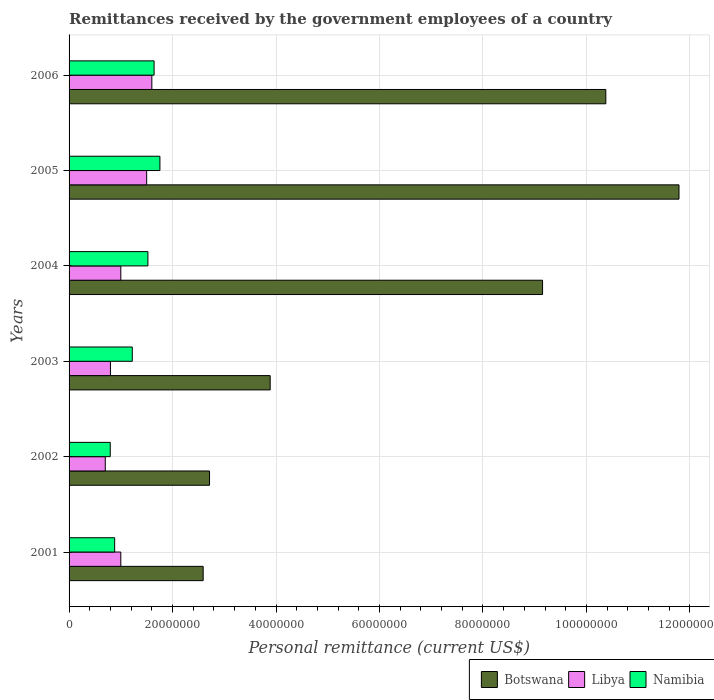How many different coloured bars are there?
Your answer should be compact. 3. How many groups of bars are there?
Your answer should be compact. 6. Are the number of bars on each tick of the Y-axis equal?
Offer a very short reply. Yes. How many bars are there on the 4th tick from the bottom?
Offer a very short reply. 3. What is the label of the 6th group of bars from the top?
Offer a very short reply. 2001. What is the remittances received by the government employees in Botswana in 2002?
Your response must be concise. 2.72e+07. Across all years, what is the maximum remittances received by the government employees in Libya?
Your answer should be very brief. 1.60e+07. Across all years, what is the minimum remittances received by the government employees in Botswana?
Provide a short and direct response. 2.59e+07. In which year was the remittances received by the government employees in Libya maximum?
Ensure brevity in your answer.  2006. What is the total remittances received by the government employees in Libya in the graph?
Your answer should be very brief. 6.60e+07. What is the difference between the remittances received by the government employees in Botswana in 2001 and that in 2005?
Provide a succinct answer. -9.20e+07. What is the difference between the remittances received by the government employees in Namibia in 2005 and the remittances received by the government employees in Botswana in 2003?
Your response must be concise. -2.13e+07. What is the average remittances received by the government employees in Botswana per year?
Provide a succinct answer. 6.75e+07. In the year 2006, what is the difference between the remittances received by the government employees in Libya and remittances received by the government employees in Namibia?
Keep it short and to the point. -4.33e+05. Is the remittances received by the government employees in Libya in 2003 less than that in 2004?
Provide a succinct answer. Yes. What is the difference between the highest and the second highest remittances received by the government employees in Namibia?
Offer a very short reply. 1.13e+06. What is the difference between the highest and the lowest remittances received by the government employees in Botswana?
Your response must be concise. 9.20e+07. In how many years, is the remittances received by the government employees in Namibia greater than the average remittances received by the government employees in Namibia taken over all years?
Make the answer very short. 3. What does the 1st bar from the top in 2003 represents?
Provide a succinct answer. Namibia. What does the 3rd bar from the bottom in 2001 represents?
Provide a succinct answer. Namibia. How many bars are there?
Keep it short and to the point. 18. Are all the bars in the graph horizontal?
Give a very brief answer. Yes. Are the values on the major ticks of X-axis written in scientific E-notation?
Ensure brevity in your answer.  No. Does the graph contain any zero values?
Provide a succinct answer. No. Where does the legend appear in the graph?
Offer a terse response. Bottom right. How many legend labels are there?
Your answer should be compact. 3. How are the legend labels stacked?
Give a very brief answer. Horizontal. What is the title of the graph?
Give a very brief answer. Remittances received by the government employees of a country. Does "Italy" appear as one of the legend labels in the graph?
Make the answer very short. No. What is the label or title of the X-axis?
Provide a short and direct response. Personal remittance (current US$). What is the Personal remittance (current US$) of Botswana in 2001?
Give a very brief answer. 2.59e+07. What is the Personal remittance (current US$) in Namibia in 2001?
Your answer should be very brief. 8.82e+06. What is the Personal remittance (current US$) of Botswana in 2002?
Make the answer very short. 2.72e+07. What is the Personal remittance (current US$) in Namibia in 2002?
Your response must be concise. 7.96e+06. What is the Personal remittance (current US$) of Botswana in 2003?
Ensure brevity in your answer.  3.89e+07. What is the Personal remittance (current US$) in Libya in 2003?
Your answer should be very brief. 8.00e+06. What is the Personal remittance (current US$) of Namibia in 2003?
Keep it short and to the point. 1.22e+07. What is the Personal remittance (current US$) in Botswana in 2004?
Keep it short and to the point. 9.15e+07. What is the Personal remittance (current US$) in Namibia in 2004?
Offer a terse response. 1.52e+07. What is the Personal remittance (current US$) of Botswana in 2005?
Give a very brief answer. 1.18e+08. What is the Personal remittance (current US$) in Libya in 2005?
Provide a succinct answer. 1.50e+07. What is the Personal remittance (current US$) of Namibia in 2005?
Offer a very short reply. 1.76e+07. What is the Personal remittance (current US$) of Botswana in 2006?
Your answer should be very brief. 1.04e+08. What is the Personal remittance (current US$) in Libya in 2006?
Your response must be concise. 1.60e+07. What is the Personal remittance (current US$) in Namibia in 2006?
Your answer should be very brief. 1.64e+07. Across all years, what is the maximum Personal remittance (current US$) in Botswana?
Your answer should be compact. 1.18e+08. Across all years, what is the maximum Personal remittance (current US$) in Libya?
Provide a succinct answer. 1.60e+07. Across all years, what is the maximum Personal remittance (current US$) in Namibia?
Provide a short and direct response. 1.76e+07. Across all years, what is the minimum Personal remittance (current US$) in Botswana?
Offer a very short reply. 2.59e+07. Across all years, what is the minimum Personal remittance (current US$) of Namibia?
Your response must be concise. 7.96e+06. What is the total Personal remittance (current US$) in Botswana in the graph?
Provide a short and direct response. 4.05e+08. What is the total Personal remittance (current US$) in Libya in the graph?
Offer a very short reply. 6.60e+07. What is the total Personal remittance (current US$) in Namibia in the graph?
Offer a very short reply. 7.82e+07. What is the difference between the Personal remittance (current US$) in Botswana in 2001 and that in 2002?
Ensure brevity in your answer.  -1.23e+06. What is the difference between the Personal remittance (current US$) of Libya in 2001 and that in 2002?
Make the answer very short. 3.00e+06. What is the difference between the Personal remittance (current US$) of Namibia in 2001 and that in 2002?
Keep it short and to the point. 8.56e+05. What is the difference between the Personal remittance (current US$) in Botswana in 2001 and that in 2003?
Provide a succinct answer. -1.30e+07. What is the difference between the Personal remittance (current US$) of Namibia in 2001 and that in 2003?
Provide a succinct answer. -3.40e+06. What is the difference between the Personal remittance (current US$) in Botswana in 2001 and that in 2004?
Make the answer very short. -6.56e+07. What is the difference between the Personal remittance (current US$) in Namibia in 2001 and that in 2004?
Offer a terse response. -6.42e+06. What is the difference between the Personal remittance (current US$) of Botswana in 2001 and that in 2005?
Provide a succinct answer. -9.20e+07. What is the difference between the Personal remittance (current US$) of Libya in 2001 and that in 2005?
Keep it short and to the point. -5.00e+06. What is the difference between the Personal remittance (current US$) in Namibia in 2001 and that in 2005?
Your response must be concise. -8.75e+06. What is the difference between the Personal remittance (current US$) in Botswana in 2001 and that in 2006?
Make the answer very short. -7.78e+07. What is the difference between the Personal remittance (current US$) in Libya in 2001 and that in 2006?
Your answer should be very brief. -6.00e+06. What is the difference between the Personal remittance (current US$) in Namibia in 2001 and that in 2006?
Provide a succinct answer. -7.62e+06. What is the difference between the Personal remittance (current US$) of Botswana in 2002 and that in 2003?
Your answer should be very brief. -1.17e+07. What is the difference between the Personal remittance (current US$) of Namibia in 2002 and that in 2003?
Offer a terse response. -4.26e+06. What is the difference between the Personal remittance (current US$) in Botswana in 2002 and that in 2004?
Your answer should be compact. -6.44e+07. What is the difference between the Personal remittance (current US$) in Libya in 2002 and that in 2004?
Give a very brief answer. -3.00e+06. What is the difference between the Personal remittance (current US$) of Namibia in 2002 and that in 2004?
Your response must be concise. -7.28e+06. What is the difference between the Personal remittance (current US$) in Botswana in 2002 and that in 2005?
Your answer should be compact. -9.07e+07. What is the difference between the Personal remittance (current US$) in Libya in 2002 and that in 2005?
Ensure brevity in your answer.  -8.00e+06. What is the difference between the Personal remittance (current US$) in Namibia in 2002 and that in 2005?
Your answer should be compact. -9.60e+06. What is the difference between the Personal remittance (current US$) of Botswana in 2002 and that in 2006?
Keep it short and to the point. -7.66e+07. What is the difference between the Personal remittance (current US$) in Libya in 2002 and that in 2006?
Your response must be concise. -9.00e+06. What is the difference between the Personal remittance (current US$) of Namibia in 2002 and that in 2006?
Your answer should be very brief. -8.47e+06. What is the difference between the Personal remittance (current US$) of Botswana in 2003 and that in 2004?
Your response must be concise. -5.26e+07. What is the difference between the Personal remittance (current US$) of Namibia in 2003 and that in 2004?
Your answer should be compact. -3.02e+06. What is the difference between the Personal remittance (current US$) of Botswana in 2003 and that in 2005?
Keep it short and to the point. -7.90e+07. What is the difference between the Personal remittance (current US$) in Libya in 2003 and that in 2005?
Offer a terse response. -7.00e+06. What is the difference between the Personal remittance (current US$) in Namibia in 2003 and that in 2005?
Offer a very short reply. -5.34e+06. What is the difference between the Personal remittance (current US$) in Botswana in 2003 and that in 2006?
Ensure brevity in your answer.  -6.49e+07. What is the difference between the Personal remittance (current US$) of Libya in 2003 and that in 2006?
Give a very brief answer. -8.00e+06. What is the difference between the Personal remittance (current US$) in Namibia in 2003 and that in 2006?
Provide a succinct answer. -4.22e+06. What is the difference between the Personal remittance (current US$) of Botswana in 2004 and that in 2005?
Give a very brief answer. -2.64e+07. What is the difference between the Personal remittance (current US$) of Libya in 2004 and that in 2005?
Your response must be concise. -5.00e+06. What is the difference between the Personal remittance (current US$) in Namibia in 2004 and that in 2005?
Offer a terse response. -2.32e+06. What is the difference between the Personal remittance (current US$) in Botswana in 2004 and that in 2006?
Provide a succinct answer. -1.22e+07. What is the difference between the Personal remittance (current US$) in Libya in 2004 and that in 2006?
Give a very brief answer. -6.00e+06. What is the difference between the Personal remittance (current US$) in Namibia in 2004 and that in 2006?
Your answer should be very brief. -1.20e+06. What is the difference between the Personal remittance (current US$) of Botswana in 2005 and that in 2006?
Offer a very short reply. 1.41e+07. What is the difference between the Personal remittance (current US$) of Namibia in 2005 and that in 2006?
Your answer should be very brief. 1.13e+06. What is the difference between the Personal remittance (current US$) in Botswana in 2001 and the Personal remittance (current US$) in Libya in 2002?
Offer a terse response. 1.89e+07. What is the difference between the Personal remittance (current US$) of Botswana in 2001 and the Personal remittance (current US$) of Namibia in 2002?
Offer a very short reply. 1.80e+07. What is the difference between the Personal remittance (current US$) in Libya in 2001 and the Personal remittance (current US$) in Namibia in 2002?
Offer a terse response. 2.04e+06. What is the difference between the Personal remittance (current US$) of Botswana in 2001 and the Personal remittance (current US$) of Libya in 2003?
Provide a short and direct response. 1.79e+07. What is the difference between the Personal remittance (current US$) in Botswana in 2001 and the Personal remittance (current US$) in Namibia in 2003?
Offer a terse response. 1.37e+07. What is the difference between the Personal remittance (current US$) in Libya in 2001 and the Personal remittance (current US$) in Namibia in 2003?
Ensure brevity in your answer.  -2.22e+06. What is the difference between the Personal remittance (current US$) of Botswana in 2001 and the Personal remittance (current US$) of Libya in 2004?
Keep it short and to the point. 1.59e+07. What is the difference between the Personal remittance (current US$) of Botswana in 2001 and the Personal remittance (current US$) of Namibia in 2004?
Give a very brief answer. 1.07e+07. What is the difference between the Personal remittance (current US$) of Libya in 2001 and the Personal remittance (current US$) of Namibia in 2004?
Offer a terse response. -5.24e+06. What is the difference between the Personal remittance (current US$) of Botswana in 2001 and the Personal remittance (current US$) of Libya in 2005?
Provide a succinct answer. 1.09e+07. What is the difference between the Personal remittance (current US$) in Botswana in 2001 and the Personal remittance (current US$) in Namibia in 2005?
Your answer should be compact. 8.36e+06. What is the difference between the Personal remittance (current US$) of Libya in 2001 and the Personal remittance (current US$) of Namibia in 2005?
Make the answer very short. -7.56e+06. What is the difference between the Personal remittance (current US$) of Botswana in 2001 and the Personal remittance (current US$) of Libya in 2006?
Your answer should be very brief. 9.92e+06. What is the difference between the Personal remittance (current US$) of Botswana in 2001 and the Personal remittance (current US$) of Namibia in 2006?
Your answer should be very brief. 9.49e+06. What is the difference between the Personal remittance (current US$) in Libya in 2001 and the Personal remittance (current US$) in Namibia in 2006?
Your answer should be compact. -6.43e+06. What is the difference between the Personal remittance (current US$) in Botswana in 2002 and the Personal remittance (current US$) in Libya in 2003?
Provide a succinct answer. 1.92e+07. What is the difference between the Personal remittance (current US$) of Botswana in 2002 and the Personal remittance (current US$) of Namibia in 2003?
Ensure brevity in your answer.  1.49e+07. What is the difference between the Personal remittance (current US$) of Libya in 2002 and the Personal remittance (current US$) of Namibia in 2003?
Give a very brief answer. -5.22e+06. What is the difference between the Personal remittance (current US$) in Botswana in 2002 and the Personal remittance (current US$) in Libya in 2004?
Provide a succinct answer. 1.72e+07. What is the difference between the Personal remittance (current US$) in Botswana in 2002 and the Personal remittance (current US$) in Namibia in 2004?
Your answer should be compact. 1.19e+07. What is the difference between the Personal remittance (current US$) of Libya in 2002 and the Personal remittance (current US$) of Namibia in 2004?
Keep it short and to the point. -8.24e+06. What is the difference between the Personal remittance (current US$) of Botswana in 2002 and the Personal remittance (current US$) of Libya in 2005?
Provide a succinct answer. 1.22e+07. What is the difference between the Personal remittance (current US$) of Botswana in 2002 and the Personal remittance (current US$) of Namibia in 2005?
Keep it short and to the point. 9.59e+06. What is the difference between the Personal remittance (current US$) in Libya in 2002 and the Personal remittance (current US$) in Namibia in 2005?
Offer a very short reply. -1.06e+07. What is the difference between the Personal remittance (current US$) in Botswana in 2002 and the Personal remittance (current US$) in Libya in 2006?
Ensure brevity in your answer.  1.12e+07. What is the difference between the Personal remittance (current US$) in Botswana in 2002 and the Personal remittance (current US$) in Namibia in 2006?
Give a very brief answer. 1.07e+07. What is the difference between the Personal remittance (current US$) of Libya in 2002 and the Personal remittance (current US$) of Namibia in 2006?
Offer a terse response. -9.43e+06. What is the difference between the Personal remittance (current US$) in Botswana in 2003 and the Personal remittance (current US$) in Libya in 2004?
Your answer should be very brief. 2.89e+07. What is the difference between the Personal remittance (current US$) in Botswana in 2003 and the Personal remittance (current US$) in Namibia in 2004?
Provide a succinct answer. 2.36e+07. What is the difference between the Personal remittance (current US$) in Libya in 2003 and the Personal remittance (current US$) in Namibia in 2004?
Provide a succinct answer. -7.24e+06. What is the difference between the Personal remittance (current US$) in Botswana in 2003 and the Personal remittance (current US$) in Libya in 2005?
Provide a short and direct response. 2.39e+07. What is the difference between the Personal remittance (current US$) in Botswana in 2003 and the Personal remittance (current US$) in Namibia in 2005?
Offer a very short reply. 2.13e+07. What is the difference between the Personal remittance (current US$) of Libya in 2003 and the Personal remittance (current US$) of Namibia in 2005?
Your answer should be compact. -9.56e+06. What is the difference between the Personal remittance (current US$) of Botswana in 2003 and the Personal remittance (current US$) of Libya in 2006?
Ensure brevity in your answer.  2.29e+07. What is the difference between the Personal remittance (current US$) in Botswana in 2003 and the Personal remittance (current US$) in Namibia in 2006?
Provide a short and direct response. 2.24e+07. What is the difference between the Personal remittance (current US$) of Libya in 2003 and the Personal remittance (current US$) of Namibia in 2006?
Your answer should be compact. -8.43e+06. What is the difference between the Personal remittance (current US$) of Botswana in 2004 and the Personal remittance (current US$) of Libya in 2005?
Provide a succinct answer. 7.65e+07. What is the difference between the Personal remittance (current US$) of Botswana in 2004 and the Personal remittance (current US$) of Namibia in 2005?
Your response must be concise. 7.40e+07. What is the difference between the Personal remittance (current US$) in Libya in 2004 and the Personal remittance (current US$) in Namibia in 2005?
Your answer should be very brief. -7.56e+06. What is the difference between the Personal remittance (current US$) in Botswana in 2004 and the Personal remittance (current US$) in Libya in 2006?
Your response must be concise. 7.55e+07. What is the difference between the Personal remittance (current US$) in Botswana in 2004 and the Personal remittance (current US$) in Namibia in 2006?
Offer a very short reply. 7.51e+07. What is the difference between the Personal remittance (current US$) in Libya in 2004 and the Personal remittance (current US$) in Namibia in 2006?
Your response must be concise. -6.43e+06. What is the difference between the Personal remittance (current US$) in Botswana in 2005 and the Personal remittance (current US$) in Libya in 2006?
Provide a succinct answer. 1.02e+08. What is the difference between the Personal remittance (current US$) of Botswana in 2005 and the Personal remittance (current US$) of Namibia in 2006?
Offer a terse response. 1.01e+08. What is the difference between the Personal remittance (current US$) in Libya in 2005 and the Personal remittance (current US$) in Namibia in 2006?
Your answer should be compact. -1.43e+06. What is the average Personal remittance (current US$) of Botswana per year?
Make the answer very short. 6.75e+07. What is the average Personal remittance (current US$) in Libya per year?
Your response must be concise. 1.10e+07. What is the average Personal remittance (current US$) of Namibia per year?
Offer a very short reply. 1.30e+07. In the year 2001, what is the difference between the Personal remittance (current US$) in Botswana and Personal remittance (current US$) in Libya?
Keep it short and to the point. 1.59e+07. In the year 2001, what is the difference between the Personal remittance (current US$) in Botswana and Personal remittance (current US$) in Namibia?
Your response must be concise. 1.71e+07. In the year 2001, what is the difference between the Personal remittance (current US$) of Libya and Personal remittance (current US$) of Namibia?
Make the answer very short. 1.18e+06. In the year 2002, what is the difference between the Personal remittance (current US$) in Botswana and Personal remittance (current US$) in Libya?
Give a very brief answer. 2.02e+07. In the year 2002, what is the difference between the Personal remittance (current US$) in Botswana and Personal remittance (current US$) in Namibia?
Provide a succinct answer. 1.92e+07. In the year 2002, what is the difference between the Personal remittance (current US$) of Libya and Personal remittance (current US$) of Namibia?
Make the answer very short. -9.60e+05. In the year 2003, what is the difference between the Personal remittance (current US$) of Botswana and Personal remittance (current US$) of Libya?
Your response must be concise. 3.09e+07. In the year 2003, what is the difference between the Personal remittance (current US$) in Botswana and Personal remittance (current US$) in Namibia?
Your response must be concise. 2.67e+07. In the year 2003, what is the difference between the Personal remittance (current US$) of Libya and Personal remittance (current US$) of Namibia?
Make the answer very short. -4.22e+06. In the year 2004, what is the difference between the Personal remittance (current US$) in Botswana and Personal remittance (current US$) in Libya?
Offer a very short reply. 8.15e+07. In the year 2004, what is the difference between the Personal remittance (current US$) of Botswana and Personal remittance (current US$) of Namibia?
Give a very brief answer. 7.63e+07. In the year 2004, what is the difference between the Personal remittance (current US$) in Libya and Personal remittance (current US$) in Namibia?
Ensure brevity in your answer.  -5.24e+06. In the year 2005, what is the difference between the Personal remittance (current US$) of Botswana and Personal remittance (current US$) of Libya?
Keep it short and to the point. 1.03e+08. In the year 2005, what is the difference between the Personal remittance (current US$) of Botswana and Personal remittance (current US$) of Namibia?
Offer a terse response. 1.00e+08. In the year 2005, what is the difference between the Personal remittance (current US$) in Libya and Personal remittance (current US$) in Namibia?
Your response must be concise. -2.56e+06. In the year 2006, what is the difference between the Personal remittance (current US$) in Botswana and Personal remittance (current US$) in Libya?
Provide a short and direct response. 8.77e+07. In the year 2006, what is the difference between the Personal remittance (current US$) in Botswana and Personal remittance (current US$) in Namibia?
Offer a very short reply. 8.73e+07. In the year 2006, what is the difference between the Personal remittance (current US$) of Libya and Personal remittance (current US$) of Namibia?
Make the answer very short. -4.33e+05. What is the ratio of the Personal remittance (current US$) of Botswana in 2001 to that in 2002?
Your answer should be compact. 0.95. What is the ratio of the Personal remittance (current US$) in Libya in 2001 to that in 2002?
Your answer should be very brief. 1.43. What is the ratio of the Personal remittance (current US$) in Namibia in 2001 to that in 2002?
Your response must be concise. 1.11. What is the ratio of the Personal remittance (current US$) of Botswana in 2001 to that in 2003?
Keep it short and to the point. 0.67. What is the ratio of the Personal remittance (current US$) of Namibia in 2001 to that in 2003?
Your answer should be very brief. 0.72. What is the ratio of the Personal remittance (current US$) of Botswana in 2001 to that in 2004?
Give a very brief answer. 0.28. What is the ratio of the Personal remittance (current US$) of Namibia in 2001 to that in 2004?
Ensure brevity in your answer.  0.58. What is the ratio of the Personal remittance (current US$) of Botswana in 2001 to that in 2005?
Give a very brief answer. 0.22. What is the ratio of the Personal remittance (current US$) of Libya in 2001 to that in 2005?
Provide a short and direct response. 0.67. What is the ratio of the Personal remittance (current US$) in Namibia in 2001 to that in 2005?
Provide a short and direct response. 0.5. What is the ratio of the Personal remittance (current US$) in Botswana in 2001 to that in 2006?
Ensure brevity in your answer.  0.25. What is the ratio of the Personal remittance (current US$) in Libya in 2001 to that in 2006?
Offer a terse response. 0.62. What is the ratio of the Personal remittance (current US$) of Namibia in 2001 to that in 2006?
Your answer should be very brief. 0.54. What is the ratio of the Personal remittance (current US$) of Botswana in 2002 to that in 2003?
Offer a very short reply. 0.7. What is the ratio of the Personal remittance (current US$) of Namibia in 2002 to that in 2003?
Ensure brevity in your answer.  0.65. What is the ratio of the Personal remittance (current US$) in Botswana in 2002 to that in 2004?
Ensure brevity in your answer.  0.3. What is the ratio of the Personal remittance (current US$) in Libya in 2002 to that in 2004?
Provide a short and direct response. 0.7. What is the ratio of the Personal remittance (current US$) in Namibia in 2002 to that in 2004?
Give a very brief answer. 0.52. What is the ratio of the Personal remittance (current US$) in Botswana in 2002 to that in 2005?
Provide a short and direct response. 0.23. What is the ratio of the Personal remittance (current US$) in Libya in 2002 to that in 2005?
Offer a very short reply. 0.47. What is the ratio of the Personal remittance (current US$) in Namibia in 2002 to that in 2005?
Offer a very short reply. 0.45. What is the ratio of the Personal remittance (current US$) in Botswana in 2002 to that in 2006?
Your answer should be compact. 0.26. What is the ratio of the Personal remittance (current US$) of Libya in 2002 to that in 2006?
Offer a terse response. 0.44. What is the ratio of the Personal remittance (current US$) in Namibia in 2002 to that in 2006?
Your answer should be very brief. 0.48. What is the ratio of the Personal remittance (current US$) of Botswana in 2003 to that in 2004?
Provide a short and direct response. 0.42. What is the ratio of the Personal remittance (current US$) in Libya in 2003 to that in 2004?
Your answer should be very brief. 0.8. What is the ratio of the Personal remittance (current US$) in Namibia in 2003 to that in 2004?
Give a very brief answer. 0.8. What is the ratio of the Personal remittance (current US$) of Botswana in 2003 to that in 2005?
Make the answer very short. 0.33. What is the ratio of the Personal remittance (current US$) in Libya in 2003 to that in 2005?
Provide a succinct answer. 0.53. What is the ratio of the Personal remittance (current US$) of Namibia in 2003 to that in 2005?
Ensure brevity in your answer.  0.7. What is the ratio of the Personal remittance (current US$) in Botswana in 2003 to that in 2006?
Offer a terse response. 0.37. What is the ratio of the Personal remittance (current US$) in Namibia in 2003 to that in 2006?
Provide a short and direct response. 0.74. What is the ratio of the Personal remittance (current US$) in Botswana in 2004 to that in 2005?
Ensure brevity in your answer.  0.78. What is the ratio of the Personal remittance (current US$) in Namibia in 2004 to that in 2005?
Give a very brief answer. 0.87. What is the ratio of the Personal remittance (current US$) in Botswana in 2004 to that in 2006?
Offer a very short reply. 0.88. What is the ratio of the Personal remittance (current US$) of Libya in 2004 to that in 2006?
Your response must be concise. 0.62. What is the ratio of the Personal remittance (current US$) in Namibia in 2004 to that in 2006?
Provide a succinct answer. 0.93. What is the ratio of the Personal remittance (current US$) of Botswana in 2005 to that in 2006?
Your answer should be very brief. 1.14. What is the ratio of the Personal remittance (current US$) in Libya in 2005 to that in 2006?
Give a very brief answer. 0.94. What is the ratio of the Personal remittance (current US$) in Namibia in 2005 to that in 2006?
Offer a very short reply. 1.07. What is the difference between the highest and the second highest Personal remittance (current US$) in Botswana?
Offer a terse response. 1.41e+07. What is the difference between the highest and the second highest Personal remittance (current US$) in Namibia?
Provide a short and direct response. 1.13e+06. What is the difference between the highest and the lowest Personal remittance (current US$) of Botswana?
Provide a succinct answer. 9.20e+07. What is the difference between the highest and the lowest Personal remittance (current US$) of Libya?
Provide a succinct answer. 9.00e+06. What is the difference between the highest and the lowest Personal remittance (current US$) in Namibia?
Offer a terse response. 9.60e+06. 